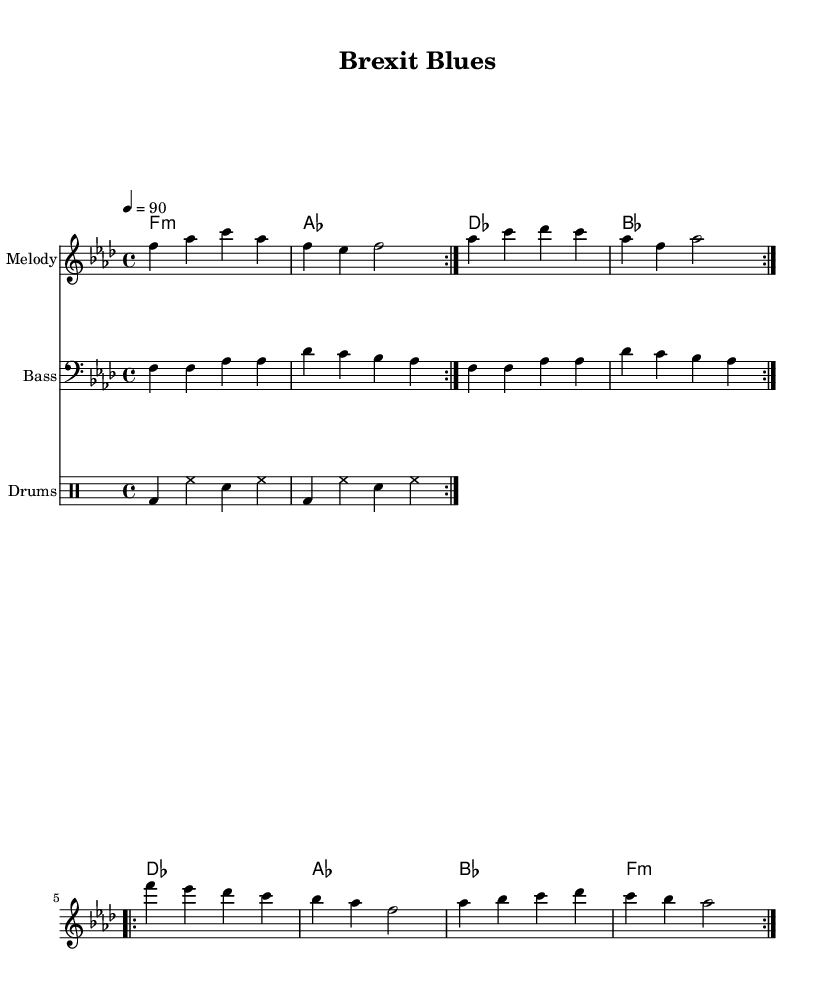What is the key signature of this music? The key signature indicates the key of F minor, which has four flats. You can determine the key signature by looking at the beginning of the staff where the flats are placed.
Answer: F minor What is the time signature of this music? The time signature shown at the beginning of the staff is 4/4, meaning there are four beats in each measure and a quarter note receives one beat. You can find this at the start of the score.
Answer: 4/4 What is the tempo marking for this piece? The tempo marking is indicated as a quarter note equals 90 BPM. This provides the speed at which the piece should be played, as seen in the tempo indication after the time signature.
Answer: 90 How many bars are there in the repeated section of the melody? The repeated section of the melody consists of four bars. You can identify this by counting the measures in the melody segment specified to repeat. Each repeat sign indicates the phrase that should be played again.
Answer: 4 What is the main chord used in the first half of the chord progression? The main chord in the first half of the chord progression is F minor. This can be seen in the chord names that are listed above the melody, where the first chord appears as F:m.
Answer: F:m What is the primary rhythmic pattern used in the drum part? The primary rhythmic pattern in the drum part consists of a bass drum followed by hi-hat and snare variations. You can recognize this by analyzing the repeated drum measures which feature the bass drum paired with hi-hat and snare drum beats.
Answer: Bass-drum and hi-hat What is the overall mood conveyed by this piece based on the style? The overall mood of the piece conveys a reflective and soulful atmosphere, typical of contemporary R&B infused with political commentary. This can be inferred from the stylistic choices of melody, rhythm, and lyrics that align with emotional expression and societal themes characteristic of the genre.
Answer: Reflective 